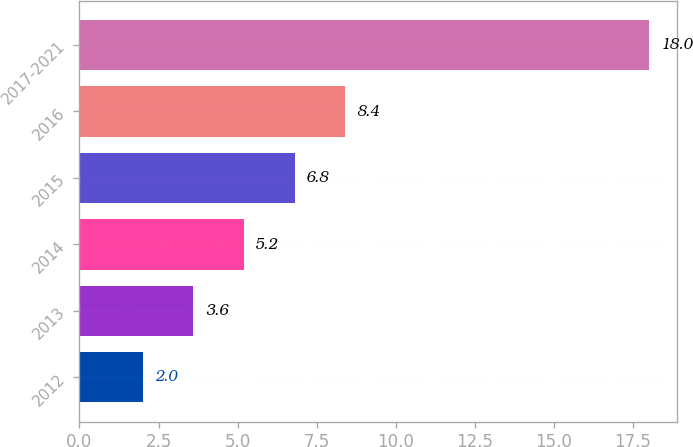Convert chart. <chart><loc_0><loc_0><loc_500><loc_500><bar_chart><fcel>2012<fcel>2013<fcel>2014<fcel>2015<fcel>2016<fcel>2017-2021<nl><fcel>2<fcel>3.6<fcel>5.2<fcel>6.8<fcel>8.4<fcel>18<nl></chart> 